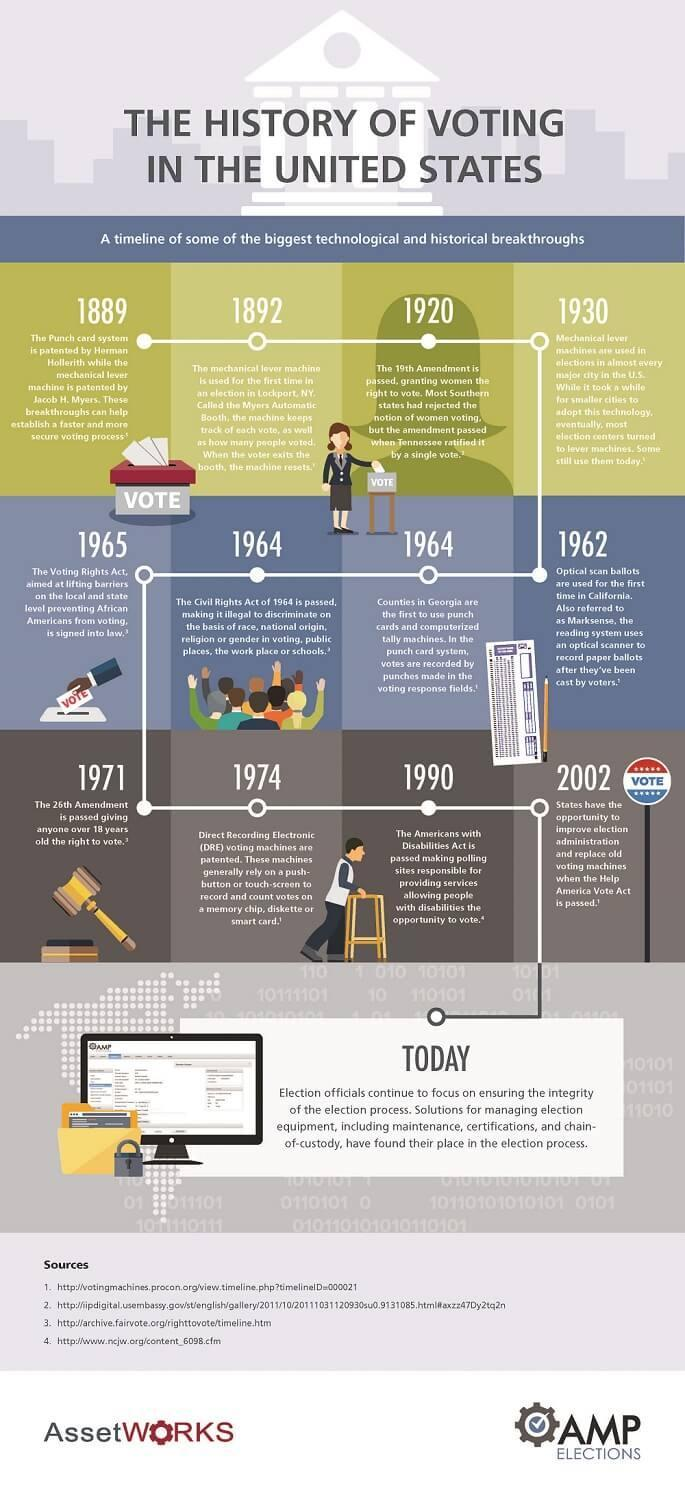When was the Americans with disability Act passed?
Answer the question with a short phrase. 1990 What does a DRE voting machines depends on for recording the votes? a push-button or touch-screen Which Amendment was passed in 1920? The 19th Amendment When was the Optical scan ballots used for the first time in California? 1962 Which Amendment was passed in 1971? The 26th Amendment When did DRE voting machines got patented? 1974 When was the Help America Vote Act passed? 2002 